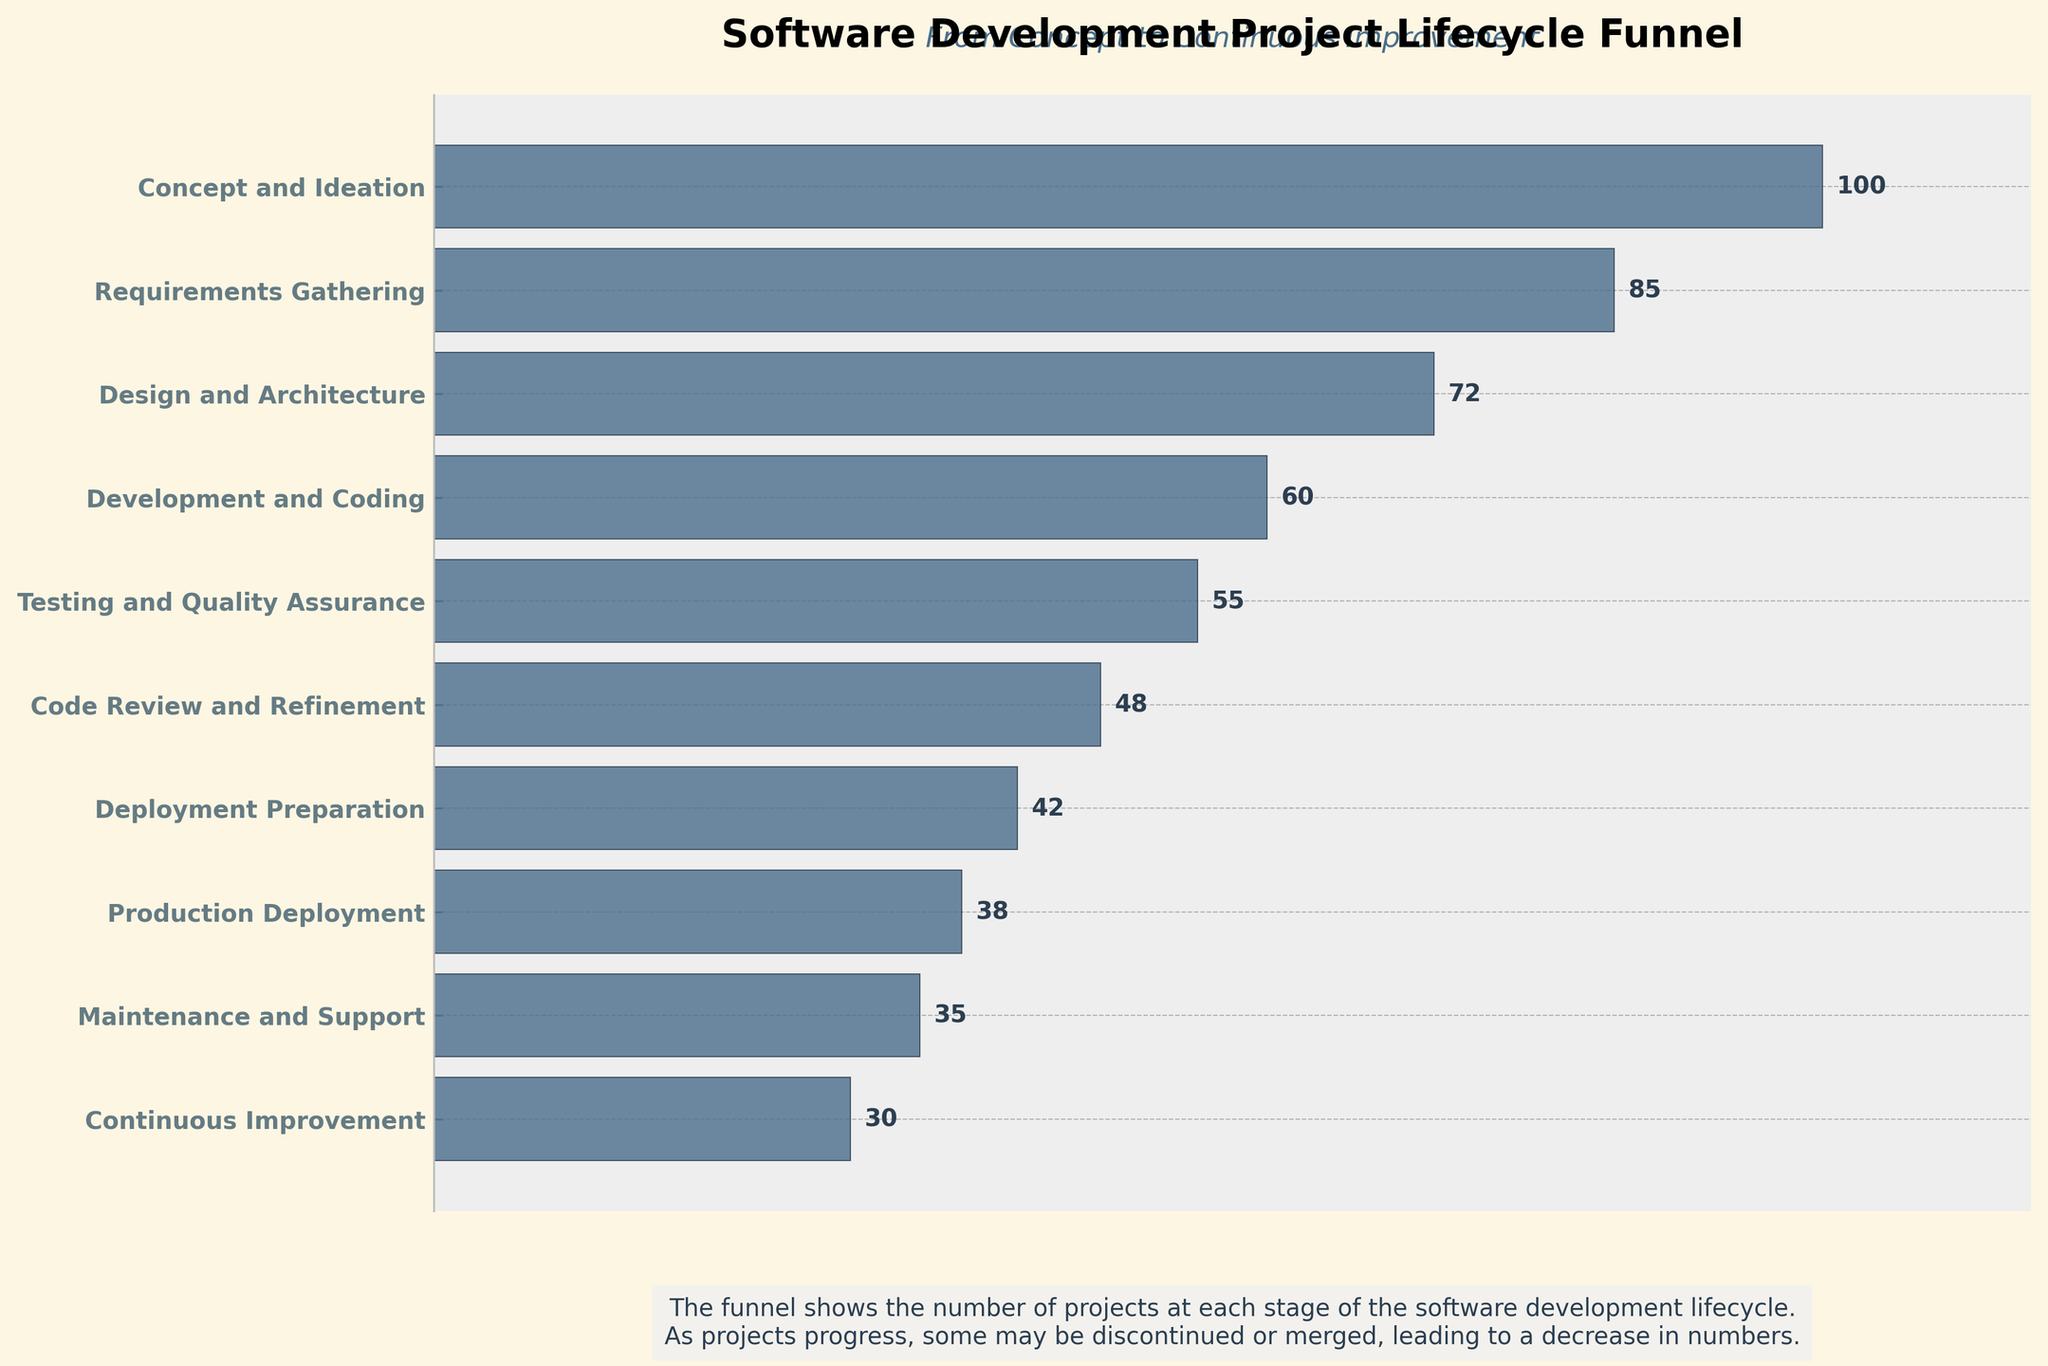What is the total number of stages in the software development lifecycle according to the funnel chart? The chart shows each stage of the lifecycle on the y-axis with labels. By counting these labels, we determine the total number of stages.
Answer: 10 What is the number of projects at the Testing and Quality Assurance stage? Refer to the y-axis to find the "Testing and Quality Assurance" label and then look directly to the right to find the corresponding number of projects displayed next to the bar.
Answer: 55 Which stage has the highest number of projects? Identify the stage with the widest bar, indicating the highest project count. According to the chart, the "Concept and Ideation" stage has the widest bar.
Answer: Concept and Ideation How many more projects are there in the Development and Coding stage compared to the Code Review and Refinement stage? Find the number of projects at both stages (60 for Development and Coding, 48 for Code Review and Refinement) and calculate the difference: 60 - 48.
Answer: 12 What's the combined number of projects beyond the Development and Coding stage? Sum the projects for all stages beyond Development and Coding: Testing and Quality Assurance (55) + Code Review and Refinement (48) + Deployment Preparation (42) + Production Deployment (38) + Maintenance and Support (35) + Continuous Improvement (30). Total = 248
Answer: 248 Which stage experiences the most significant drop in the number of projects? Calculate the differences between consecutive stages and identify the largest decrease. The difference between Concept and Ideation (100) and Requirements Gathering (85) is 15, which is the largest drop.
Answer: Concept and Ideation to Requirements Gathering Are there more projects in the Design and Architecture stage or in the Continuous Improvement stage? Compare the number of projects at both stages. Design and Architecture has 72 projects, while Continuous Improvement has 30 projects. Hence, Design and Architecture has more.
Answer: Design and Architecture How many projects are discontinued or merged from the Design and Architecture to the Development and Coding stage? Subtract the Development and Coding stage count (60) from the Design and Architecture stage count (72): 72 - 60.
Answer: 12 Among the stages Deployment Preparation, Production Deployment, and Maintenance and Support, which has the least number of projects? Compare the project numbers for Deployment Preparation (42), Production Deployment (38), and Maintenance and Support (35). Maintenance and Support has the fewest, with 35 projects.
Answer: Maintenance and Support What is the title of the figure, and what additional text is provided as a subtitle? Identify the text at the top and slightly below the top of the chart. The title is "Software Development Project Lifecycle Funnel" and the subtitle is "From Concept to Continuous Improvement."
Answer: Software Development Project Lifecycle Funnel; From Concept to Continuous Improvement 